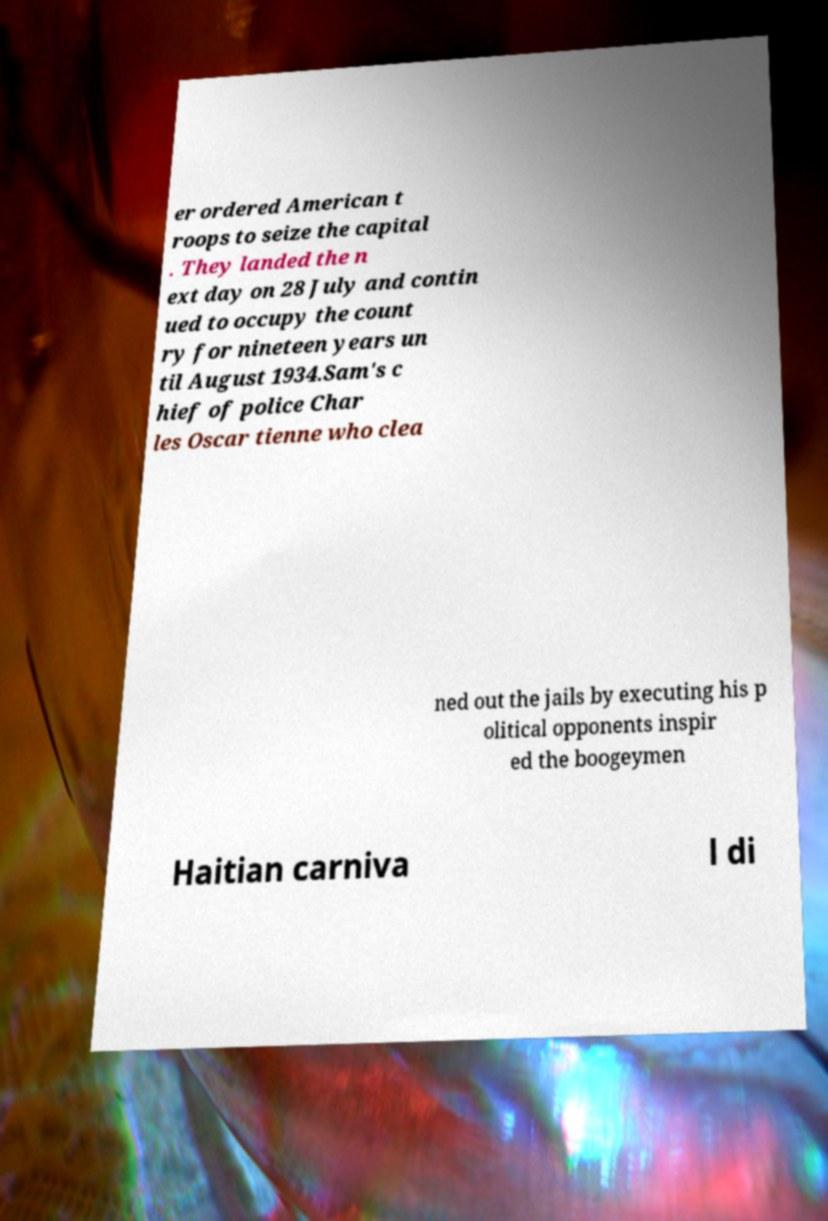Can you accurately transcribe the text from the provided image for me? er ordered American t roops to seize the capital . They landed the n ext day on 28 July and contin ued to occupy the count ry for nineteen years un til August 1934.Sam's c hief of police Char les Oscar tienne who clea ned out the jails by executing his p olitical opponents inspir ed the boogeymen Haitian carniva l di 